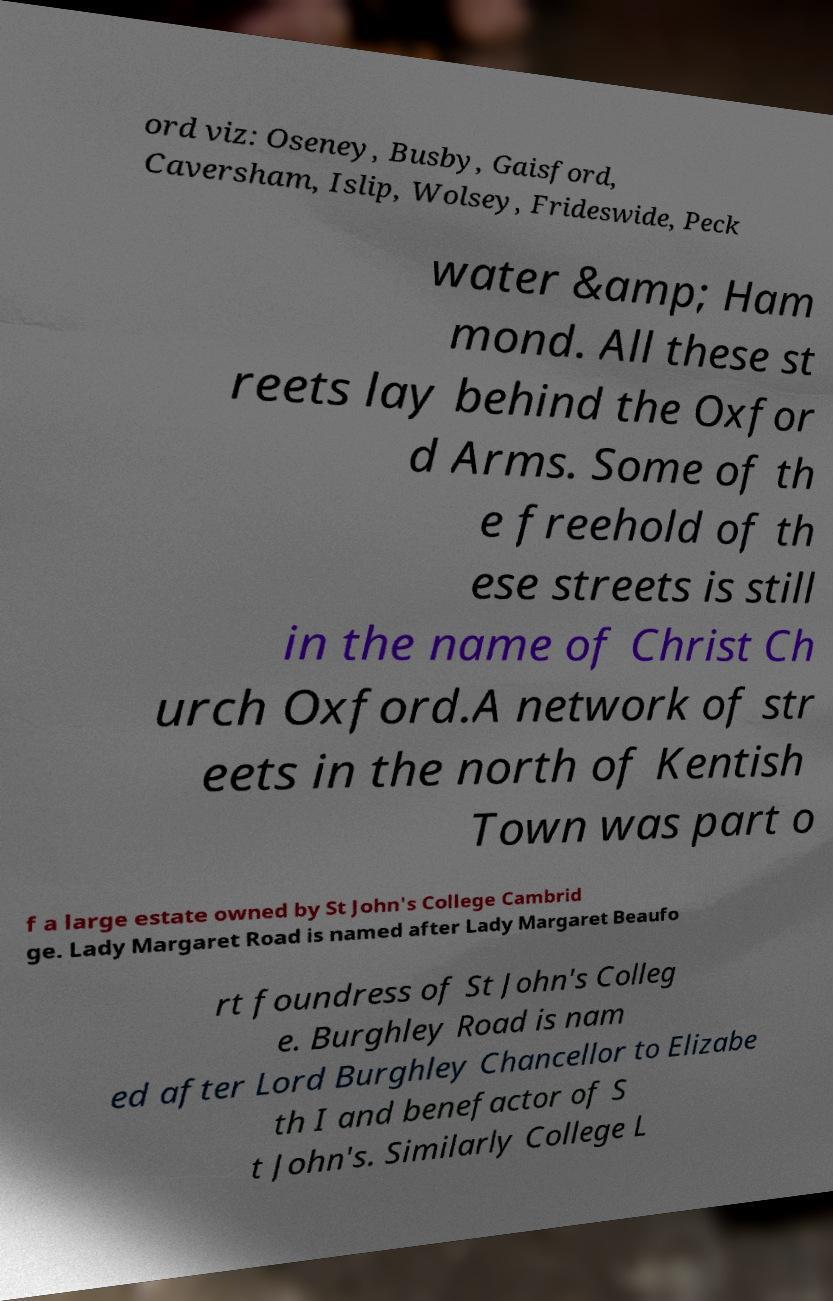Could you extract and type out the text from this image? ord viz: Oseney, Busby, Gaisford, Caversham, Islip, Wolsey, Frideswide, Peck water &amp; Ham mond. All these st reets lay behind the Oxfor d Arms. Some of th e freehold of th ese streets is still in the name of Christ Ch urch Oxford.A network of str eets in the north of Kentish Town was part o f a large estate owned by St John's College Cambrid ge. Lady Margaret Road is named after Lady Margaret Beaufo rt foundress of St John's Colleg e. Burghley Road is nam ed after Lord Burghley Chancellor to Elizabe th I and benefactor of S t John's. Similarly College L 